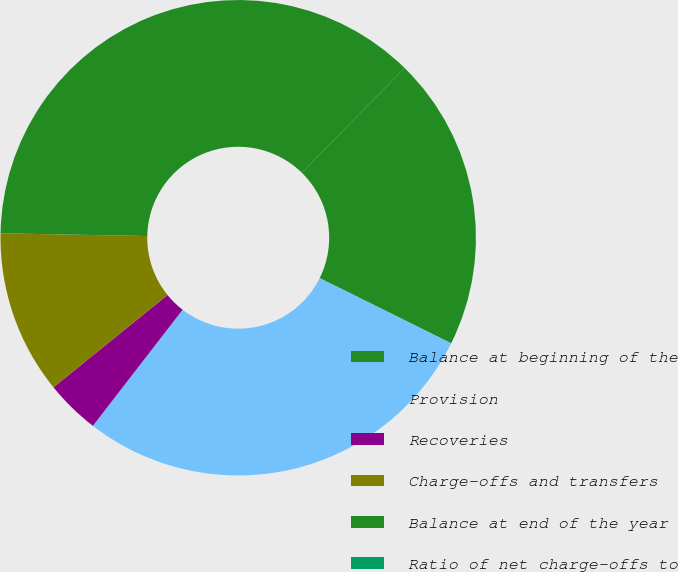Convert chart to OTSL. <chart><loc_0><loc_0><loc_500><loc_500><pie_chart><fcel>Balance at beginning of the<fcel>Provision<fcel>Recoveries<fcel>Charge-offs and transfers<fcel>Balance at end of the year<fcel>Ratio of net charge-offs to<nl><fcel>19.99%<fcel>28.14%<fcel>3.7%<fcel>11.13%<fcel>37.03%<fcel>0.0%<nl></chart> 